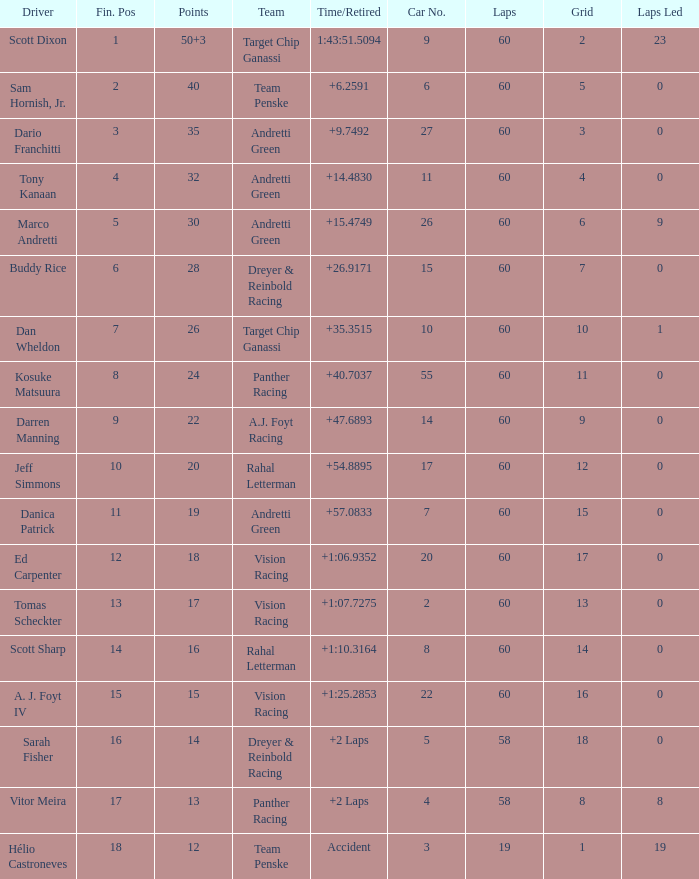Name the drive for points being 13 Vitor Meira. 